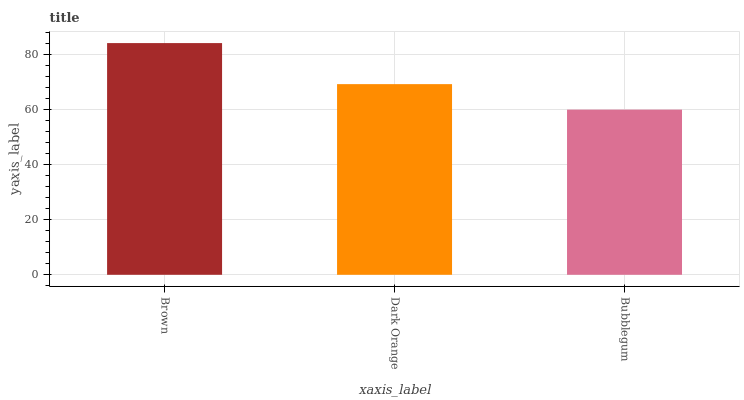Is Bubblegum the minimum?
Answer yes or no. Yes. Is Brown the maximum?
Answer yes or no. Yes. Is Dark Orange the minimum?
Answer yes or no. No. Is Dark Orange the maximum?
Answer yes or no. No. Is Brown greater than Dark Orange?
Answer yes or no. Yes. Is Dark Orange less than Brown?
Answer yes or no. Yes. Is Dark Orange greater than Brown?
Answer yes or no. No. Is Brown less than Dark Orange?
Answer yes or no. No. Is Dark Orange the high median?
Answer yes or no. Yes. Is Dark Orange the low median?
Answer yes or no. Yes. Is Brown the high median?
Answer yes or no. No. Is Bubblegum the low median?
Answer yes or no. No. 